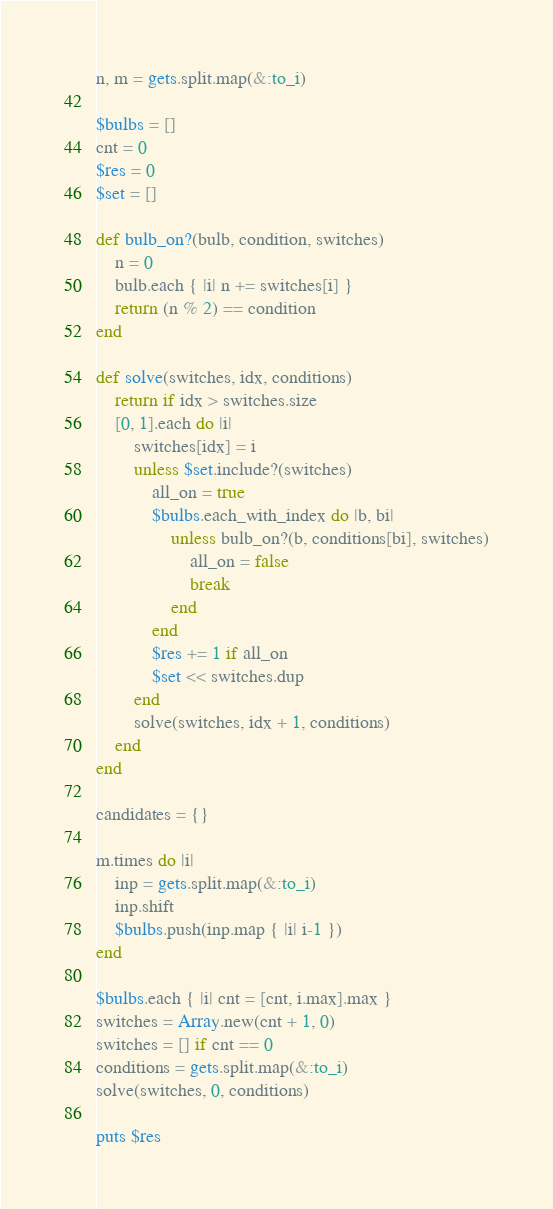Convert code to text. <code><loc_0><loc_0><loc_500><loc_500><_Ruby_>n, m = gets.split.map(&:to_i)

$bulbs = []
cnt = 0
$res = 0
$set = []

def bulb_on?(bulb, condition, switches)
    n = 0
    bulb.each { |i| n += switches[i] }
    return (n % 2) == condition
end

def solve(switches, idx, conditions)
    return if idx > switches.size
    [0, 1].each do |i|
        switches[idx] = i
        unless $set.include?(switches)
            all_on = true
            $bulbs.each_with_index do |b, bi|
                unless bulb_on?(b, conditions[bi], switches)
                    all_on = false
                    break
                end
            end
            $res += 1 if all_on
            $set << switches.dup
        end
        solve(switches, idx + 1, conditions)
    end
end

candidates = {}

m.times do |i|
    inp = gets.split.map(&:to_i)
    inp.shift
    $bulbs.push(inp.map { |i| i-1 })
end

$bulbs.each { |i| cnt = [cnt, i.max].max }
switches = Array.new(cnt + 1, 0)
switches = [] if cnt == 0
conditions = gets.split.map(&:to_i)
solve(switches, 0, conditions)

puts $res</code> 